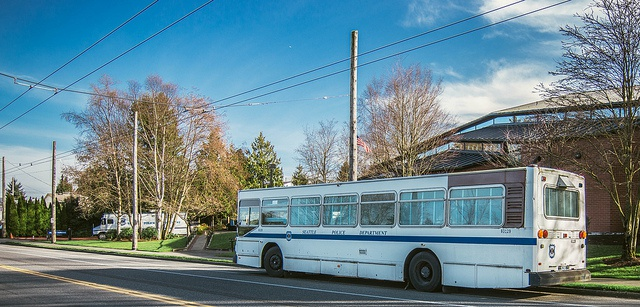Describe the objects in this image and their specific colors. I can see bus in blue, gray, lightblue, and darkgray tones and truck in blue, lightgray, darkgray, black, and gray tones in this image. 